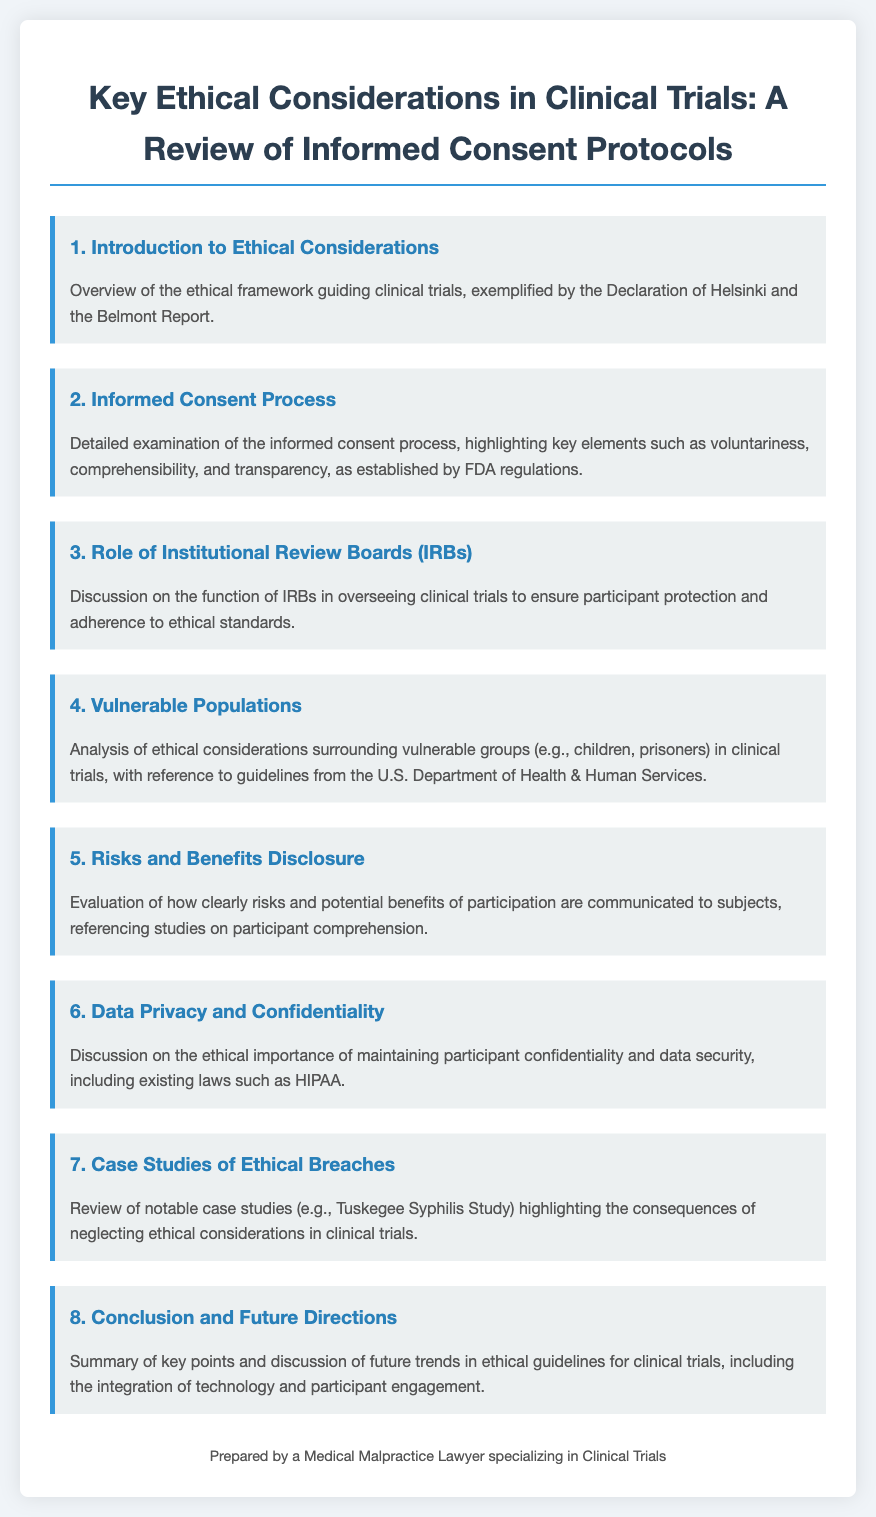What is the ethical framework guiding clinical trials? The ethical framework guiding clinical trials is exemplified by the Declaration of Helsinki and the Belmont Report.
Answer: Declaration of Helsinki and the Belmont Report What is the main focus of the informed consent process? The informed consent process highlights key elements such as voluntariness, comprehensibility, and transparency, as established by FDA regulations.
Answer: Voluntariness, comprehensibility, and transparency What is the role of Institutional Review Boards (IRBs)? IRBs oversee clinical trials to ensure participant protection and adherence to ethical standards.
Answer: Participant protection and adherence to ethical standards Which populations are discussed as vulnerable in clinical trials? Ethical considerations surrounding vulnerable groups include children and prisoners.
Answer: Children and prisoners What is evaluated in terms of participant communication? The evaluation focuses on how clearly risks and potential benefits of participation are communicated to subjects.
Answer: Risks and potential benefits What laws are referenced regarding data privacy? Existing laws such as HIPAA are discussed with regard to maintaining participant confidentiality and data security.
Answer: HIPAA What notable case study is highlighted for ethical breaches? The Tuskegee Syphilis Study is reviewed as a notable case highlighting the consequences of neglecting ethical considerations.
Answer: Tuskegee Syphilis Study What are the future directions discussed in the document? Future trends in ethical guidelines for clinical trials include the integration of technology and participant engagement.
Answer: Integration of technology and participant engagement 